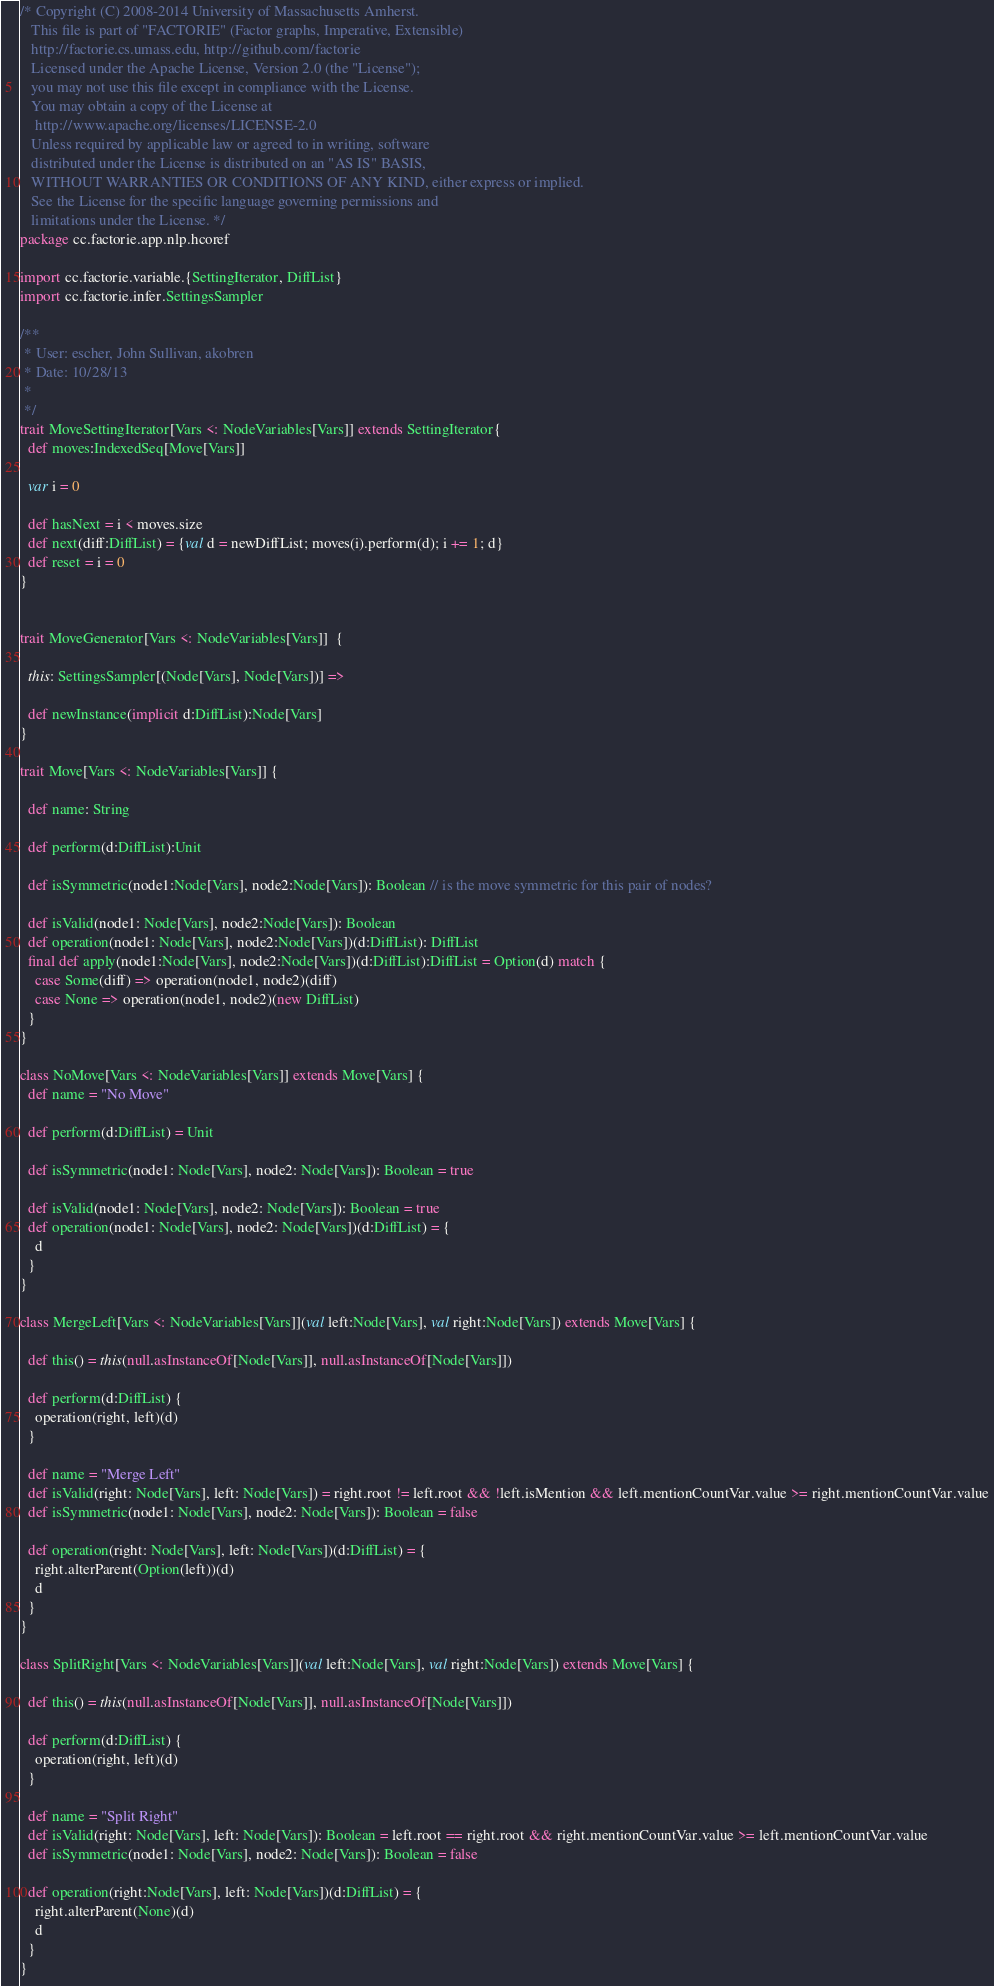<code> <loc_0><loc_0><loc_500><loc_500><_Scala_>/* Copyright (C) 2008-2014 University of Massachusetts Amherst.
   This file is part of "FACTORIE" (Factor graphs, Imperative, Extensible)
   http://factorie.cs.umass.edu, http://github.com/factorie
   Licensed under the Apache License, Version 2.0 (the "License");
   you may not use this file except in compliance with the License.
   You may obtain a copy of the License at
    http://www.apache.org/licenses/LICENSE-2.0
   Unless required by applicable law or agreed to in writing, software
   distributed under the License is distributed on an "AS IS" BASIS,
   WITHOUT WARRANTIES OR CONDITIONS OF ANY KIND, either express or implied.
   See the License for the specific language governing permissions and
   limitations under the License. */
package cc.factorie.app.nlp.hcoref

import cc.factorie.variable.{SettingIterator, DiffList}
import cc.factorie.infer.SettingsSampler

/**
 * User: escher, John Sullivan, akobren
 * Date: 10/28/13
 *
 */
trait MoveSettingIterator[Vars <: NodeVariables[Vars]] extends SettingIterator{
  def moves:IndexedSeq[Move[Vars]]

  var i = 0

  def hasNext = i < moves.size
  def next(diff:DiffList) = {val d = newDiffList; moves(i).perform(d); i += 1; d}
  def reset = i = 0
}


trait MoveGenerator[Vars <: NodeVariables[Vars]]  {

  this: SettingsSampler[(Node[Vars], Node[Vars])] =>

  def newInstance(implicit d:DiffList):Node[Vars]
}

trait Move[Vars <: NodeVariables[Vars]] {

  def name: String

  def perform(d:DiffList):Unit

  def isSymmetric(node1:Node[Vars], node2:Node[Vars]): Boolean // is the move symmetric for this pair of nodes?

  def isValid(node1: Node[Vars], node2:Node[Vars]): Boolean
  def operation(node1: Node[Vars], node2:Node[Vars])(d:DiffList): DiffList
  final def apply(node1:Node[Vars], node2:Node[Vars])(d:DiffList):DiffList = Option(d) match {
    case Some(diff) => operation(node1, node2)(diff)
    case None => operation(node1, node2)(new DiffList)
  }
}

class NoMove[Vars <: NodeVariables[Vars]] extends Move[Vars] {
  def name = "No Move"

  def perform(d:DiffList) = Unit

  def isSymmetric(node1: Node[Vars], node2: Node[Vars]): Boolean = true

  def isValid(node1: Node[Vars], node2: Node[Vars]): Boolean = true
  def operation(node1: Node[Vars], node2: Node[Vars])(d:DiffList) = {
    d
  }
}

class MergeLeft[Vars <: NodeVariables[Vars]](val left:Node[Vars], val right:Node[Vars]) extends Move[Vars] {

  def this() = this(null.asInstanceOf[Node[Vars]], null.asInstanceOf[Node[Vars]])

  def perform(d:DiffList) {
    operation(right, left)(d)
  }

  def name = "Merge Left"
  def isValid(right: Node[Vars], left: Node[Vars]) = right.root != left.root && !left.isMention && left.mentionCountVar.value >= right.mentionCountVar.value
  def isSymmetric(node1: Node[Vars], node2: Node[Vars]): Boolean = false

  def operation(right: Node[Vars], left: Node[Vars])(d:DiffList) = {
    right.alterParent(Option(left))(d)
    d
  }
}

class SplitRight[Vars <: NodeVariables[Vars]](val left:Node[Vars], val right:Node[Vars]) extends Move[Vars] {

  def this() = this(null.asInstanceOf[Node[Vars]], null.asInstanceOf[Node[Vars]])

  def perform(d:DiffList) {
    operation(right, left)(d)
  }

  def name = "Split Right"
  def isValid(right: Node[Vars], left: Node[Vars]): Boolean = left.root == right.root && right.mentionCountVar.value >= left.mentionCountVar.value
  def isSymmetric(node1: Node[Vars], node2: Node[Vars]): Boolean = false

  def operation(right:Node[Vars], left: Node[Vars])(d:DiffList) = {
    right.alterParent(None)(d)
    d
  }
}
</code> 